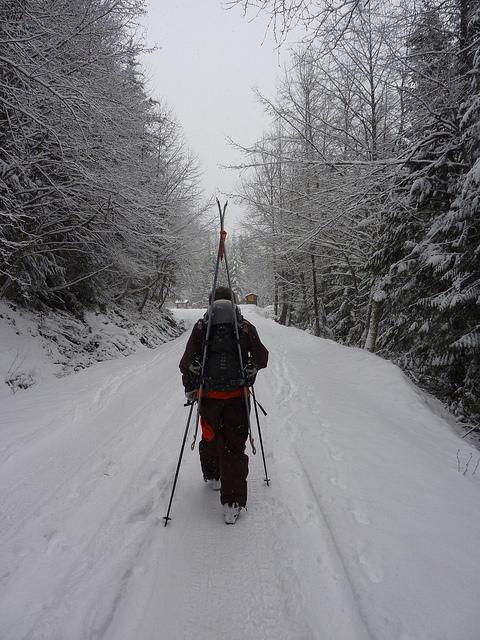What color is his jacket?
Give a very brief answer. Black. Have any vehicles been on the snow?
Answer briefly. Yes. What is the skier wearing on their back?
Answer briefly. Skis. What is the person doing?
Short answer required. Walking. What are these people wearing?
Be succinct. Snow gear. Is the person walking alone?
Answer briefly. Yes. Is it cold outside?
Be succinct. Yes. 